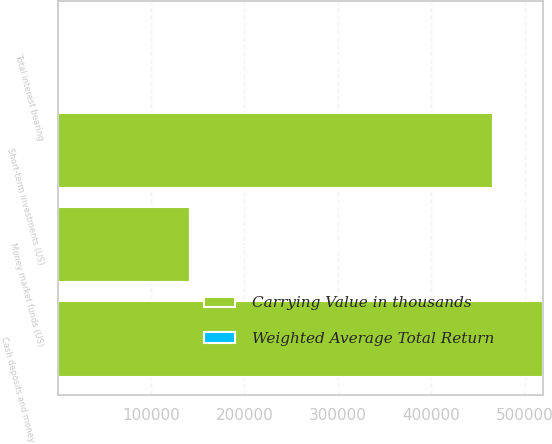Convert chart to OTSL. <chart><loc_0><loc_0><loc_500><loc_500><stacked_bar_chart><ecel><fcel>Money market funds (US)<fcel>Cash deposits and money market<fcel>Short-term investments (US)<fcel>Total interest bearing<nl><fcel>Carrying Value in thousands<fcel>141418<fcel>519805<fcel>466713<fcel>0.54<nl><fcel>Weighted Average Total Return<fcel>0.02<fcel>0.14<fcel>0.38<fcel>0.54<nl></chart> 